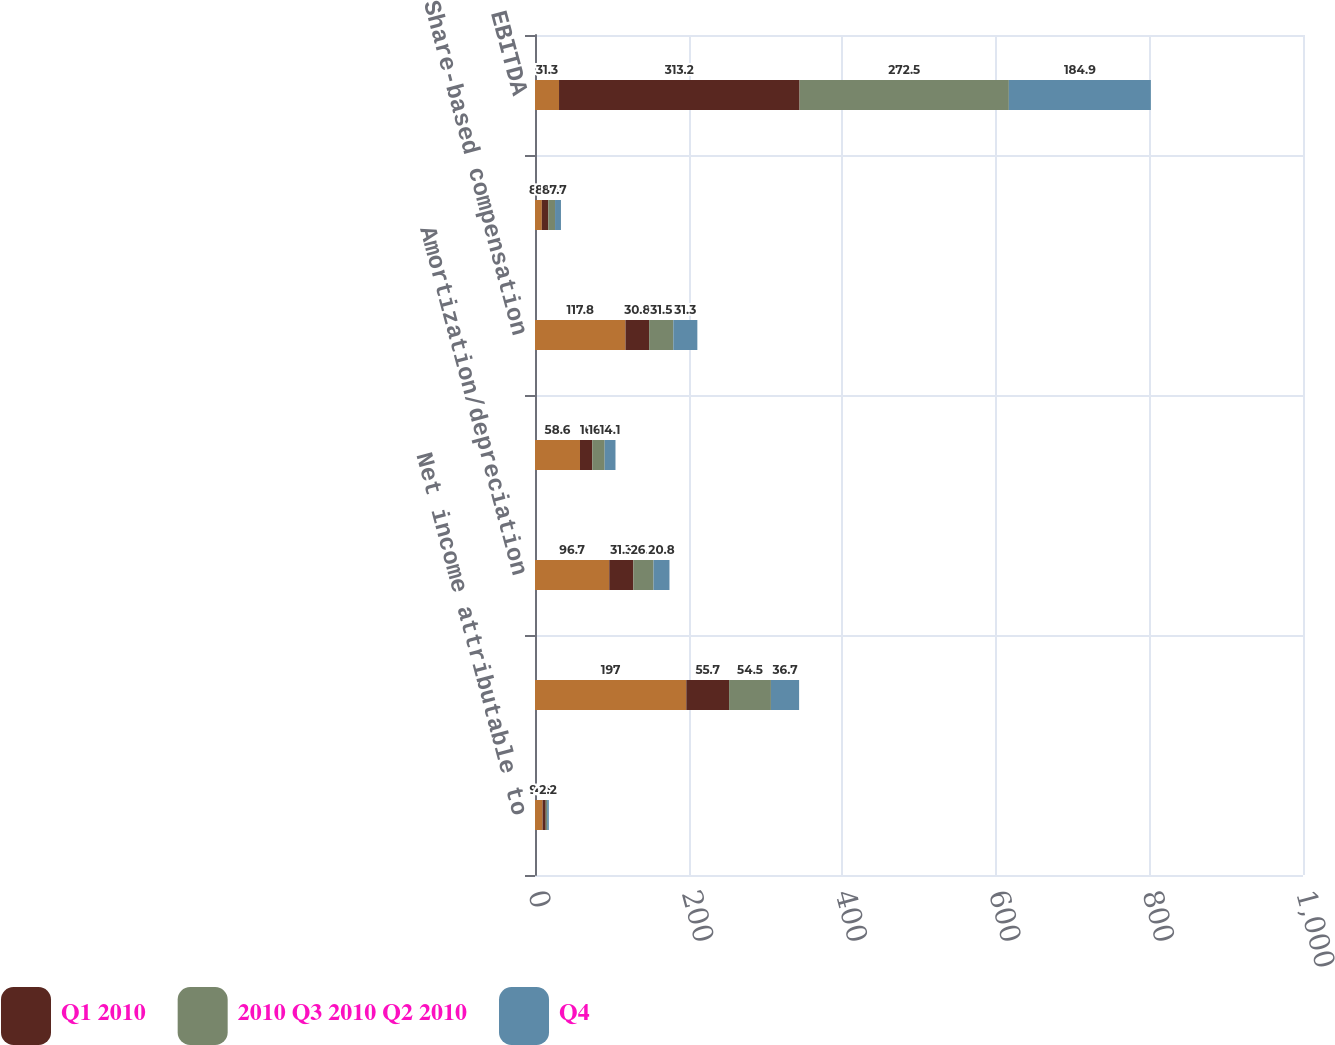Convert chart. <chart><loc_0><loc_0><loc_500><loc_500><stacked_bar_chart><ecel><fcel>Net income attributable to<fcel>Tax expense<fcel>Amortization/depreciation<fcel>Interest expense<fcel>Share-based compensation<fcel>Unrealized gains and losses<fcel>EBITDA<nl><fcel>nan<fcel>9.8<fcel>197<fcel>96.7<fcel>58.6<fcel>117.8<fcel>8.9<fcel>31.3<nl><fcel>Q1 2010<fcel>4.2<fcel>55.7<fcel>31.3<fcel>16<fcel>30.8<fcel>8.4<fcel>313.2<nl><fcel>2010 Q3 2010 Q2 2010<fcel>1.8<fcel>54.5<fcel>26.3<fcel>16.1<fcel>31.5<fcel>8.8<fcel>272.5<nl><fcel>Q4<fcel>2.2<fcel>36.7<fcel>20.8<fcel>14.1<fcel>31.3<fcel>7.7<fcel>184.9<nl></chart> 